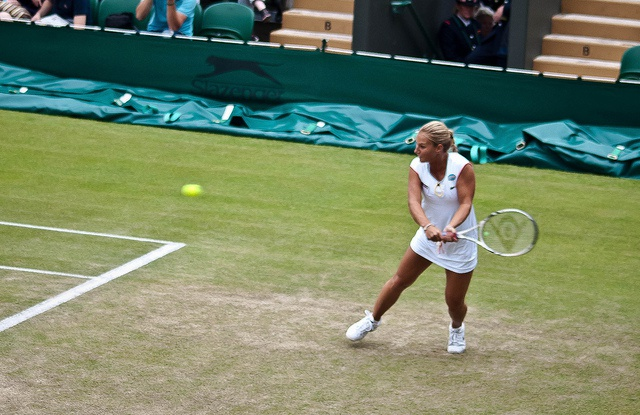Describe the objects in this image and their specific colors. I can see people in gray, lavender, maroon, and darkgray tones, tennis racket in gray, olive, darkgray, and lightgray tones, people in gray, black, and maroon tones, people in gray, blue, teal, brown, and lightblue tones, and chair in gray, teal, and black tones in this image. 